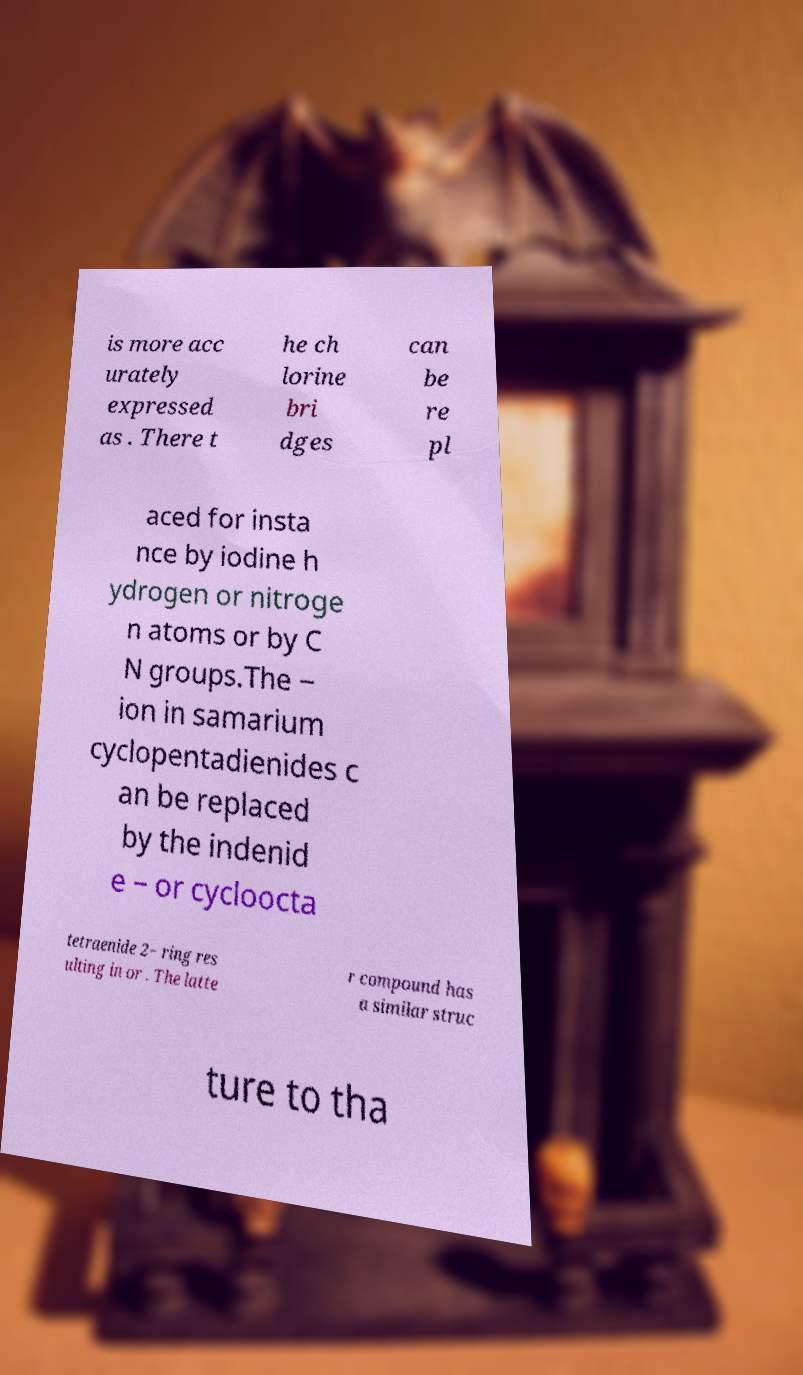There's text embedded in this image that I need extracted. Can you transcribe it verbatim? is more acc urately expressed as . There t he ch lorine bri dges can be re pl aced for insta nce by iodine h ydrogen or nitroge n atoms or by C N groups.The − ion in samarium cyclopentadienides c an be replaced by the indenid e − or cycloocta tetraenide 2− ring res ulting in or . The latte r compound has a similar struc ture to tha 